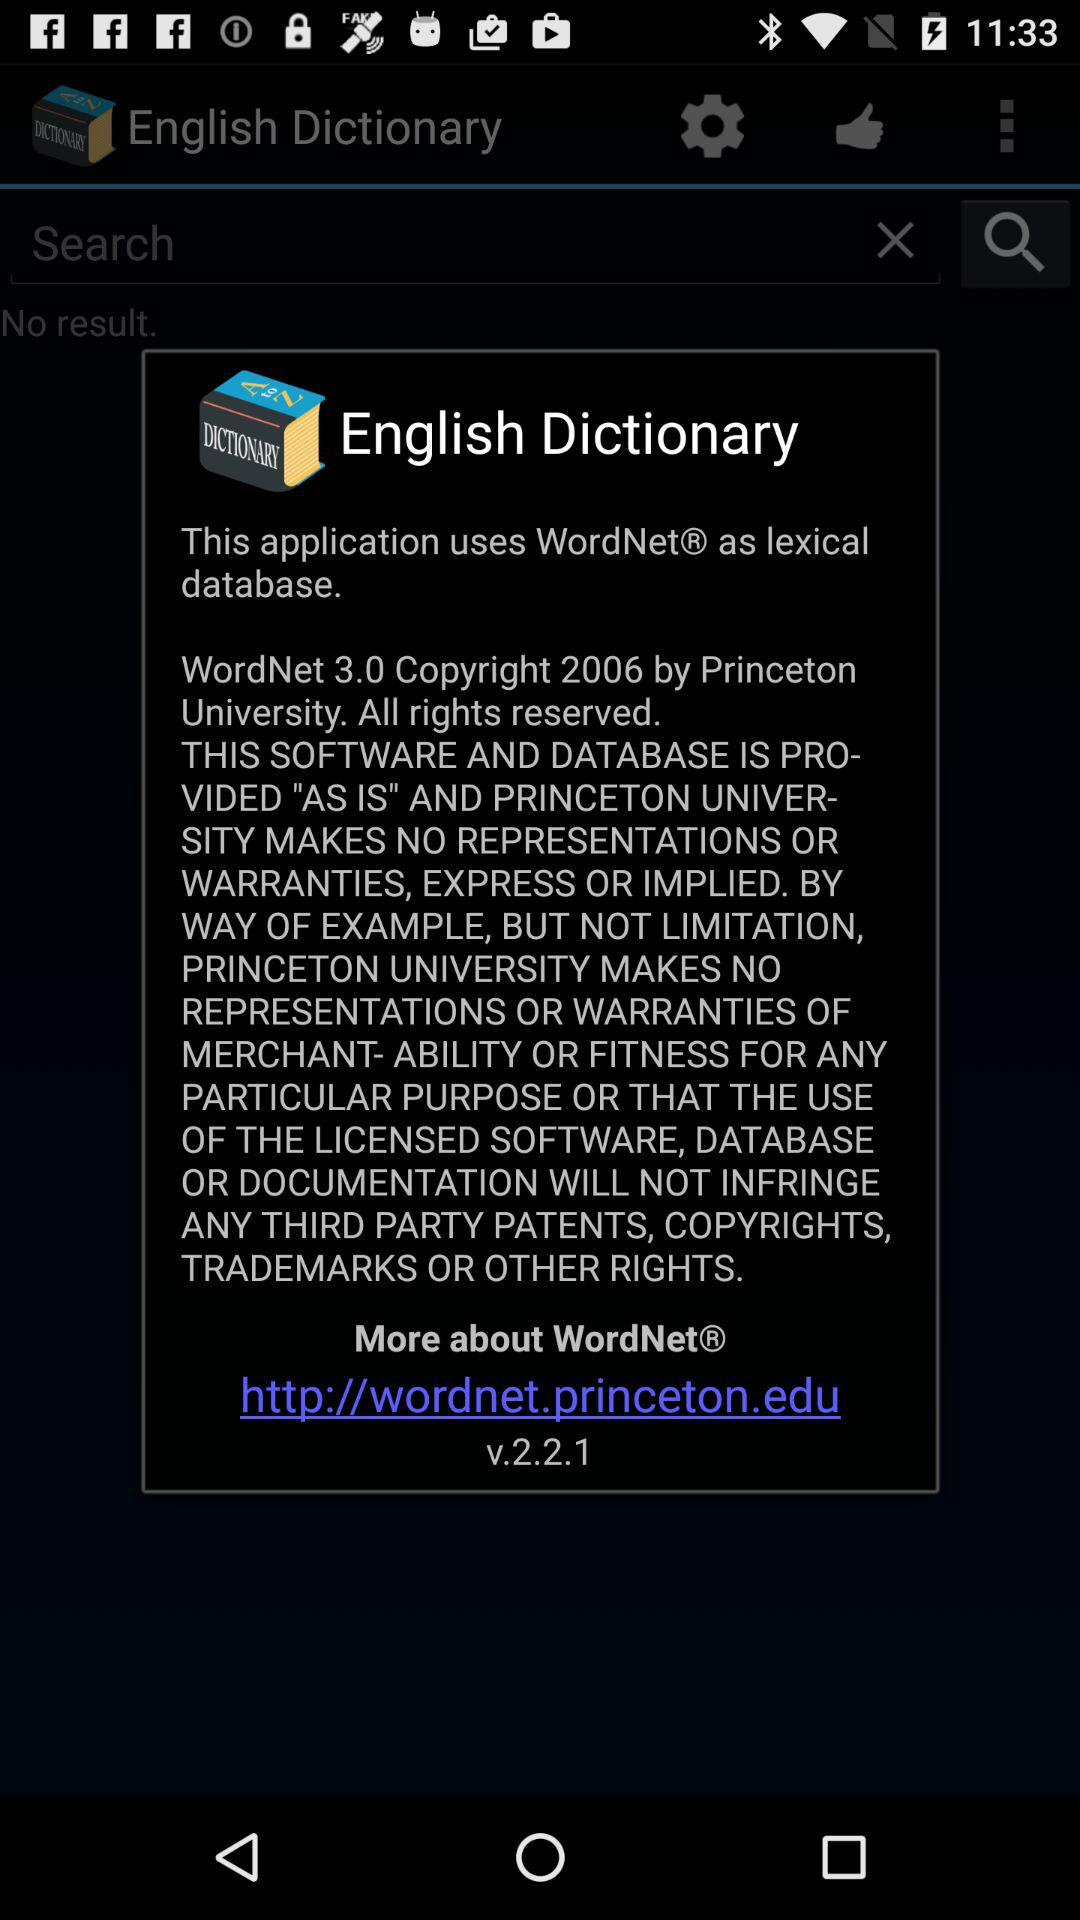What is the version of the application?
Answer the question using a single word or phrase. V2.2.1 